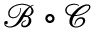Convert formula to latex. <formula><loc_0><loc_0><loc_500><loc_500>{ \mathcal { B } } \circ { \mathcal { C } }</formula> 